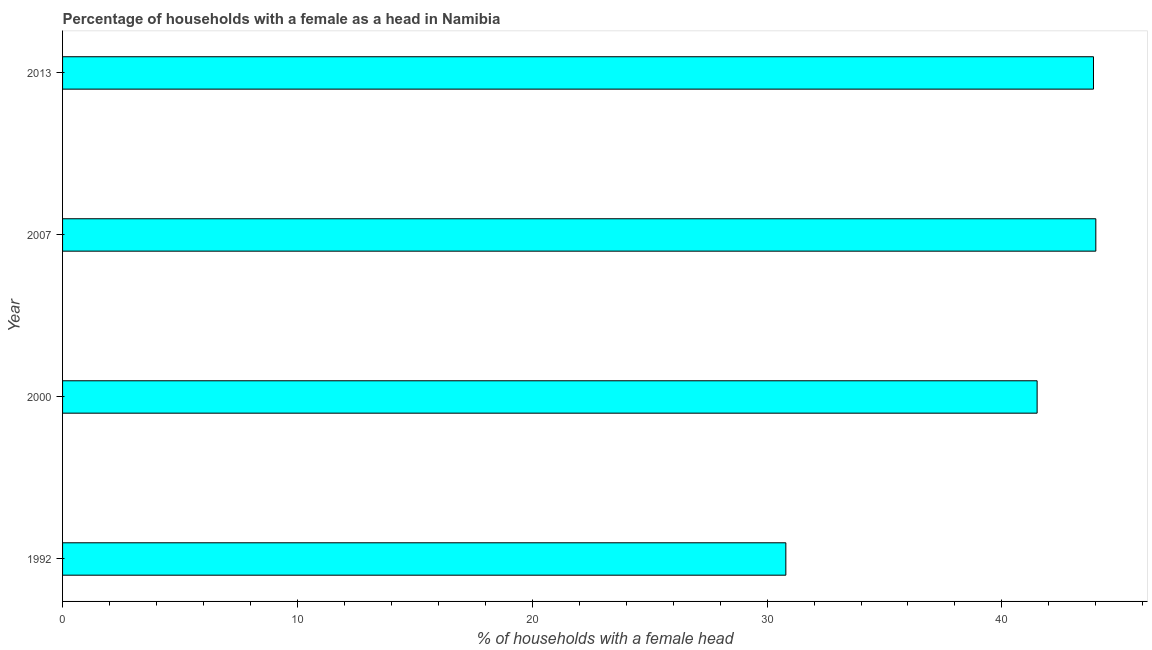Does the graph contain grids?
Your answer should be compact. No. What is the title of the graph?
Your answer should be very brief. Percentage of households with a female as a head in Namibia. What is the label or title of the X-axis?
Offer a terse response. % of households with a female head. What is the number of female supervised households in 2013?
Ensure brevity in your answer.  43.9. Across all years, what is the maximum number of female supervised households?
Keep it short and to the point. 44. Across all years, what is the minimum number of female supervised households?
Give a very brief answer. 30.8. In which year was the number of female supervised households minimum?
Make the answer very short. 1992. What is the sum of the number of female supervised households?
Give a very brief answer. 160.2. What is the difference between the number of female supervised households in 1992 and 2013?
Your answer should be very brief. -13.1. What is the average number of female supervised households per year?
Provide a short and direct response. 40.05. What is the median number of female supervised households?
Your answer should be compact. 42.7. In how many years, is the number of female supervised households greater than 36 %?
Offer a terse response. 3. Do a majority of the years between 2000 and 2007 (inclusive) have number of female supervised households greater than 20 %?
Provide a succinct answer. Yes. Is the difference between the number of female supervised households in 1992 and 2013 greater than the difference between any two years?
Keep it short and to the point. No. What is the difference between the highest and the lowest number of female supervised households?
Offer a terse response. 13.2. Are all the bars in the graph horizontal?
Give a very brief answer. Yes. Are the values on the major ticks of X-axis written in scientific E-notation?
Make the answer very short. No. What is the % of households with a female head in 1992?
Your response must be concise. 30.8. What is the % of households with a female head of 2000?
Ensure brevity in your answer.  41.5. What is the % of households with a female head in 2013?
Give a very brief answer. 43.9. What is the difference between the % of households with a female head in 1992 and 2000?
Your answer should be compact. -10.7. What is the difference between the % of households with a female head in 1992 and 2007?
Provide a short and direct response. -13.2. What is the ratio of the % of households with a female head in 1992 to that in 2000?
Provide a succinct answer. 0.74. What is the ratio of the % of households with a female head in 1992 to that in 2007?
Offer a terse response. 0.7. What is the ratio of the % of households with a female head in 1992 to that in 2013?
Ensure brevity in your answer.  0.7. What is the ratio of the % of households with a female head in 2000 to that in 2007?
Your answer should be very brief. 0.94. What is the ratio of the % of households with a female head in 2000 to that in 2013?
Make the answer very short. 0.94. 